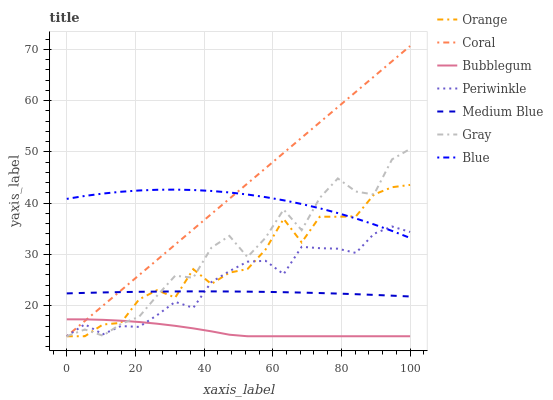Does Bubblegum have the minimum area under the curve?
Answer yes or no. Yes. Does Coral have the maximum area under the curve?
Answer yes or no. Yes. Does Gray have the minimum area under the curve?
Answer yes or no. No. Does Gray have the maximum area under the curve?
Answer yes or no. No. Is Coral the smoothest?
Answer yes or no. Yes. Is Gray the roughest?
Answer yes or no. Yes. Is Gray the smoothest?
Answer yes or no. No. Is Coral the roughest?
Answer yes or no. No. Does Gray have the lowest value?
Answer yes or no. Yes. Does Medium Blue have the lowest value?
Answer yes or no. No. Does Coral have the highest value?
Answer yes or no. Yes. Does Gray have the highest value?
Answer yes or no. No. Is Medium Blue less than Blue?
Answer yes or no. Yes. Is Medium Blue greater than Bubblegum?
Answer yes or no. Yes. Does Orange intersect Periwinkle?
Answer yes or no. Yes. Is Orange less than Periwinkle?
Answer yes or no. No. Is Orange greater than Periwinkle?
Answer yes or no. No. Does Medium Blue intersect Blue?
Answer yes or no. No. 